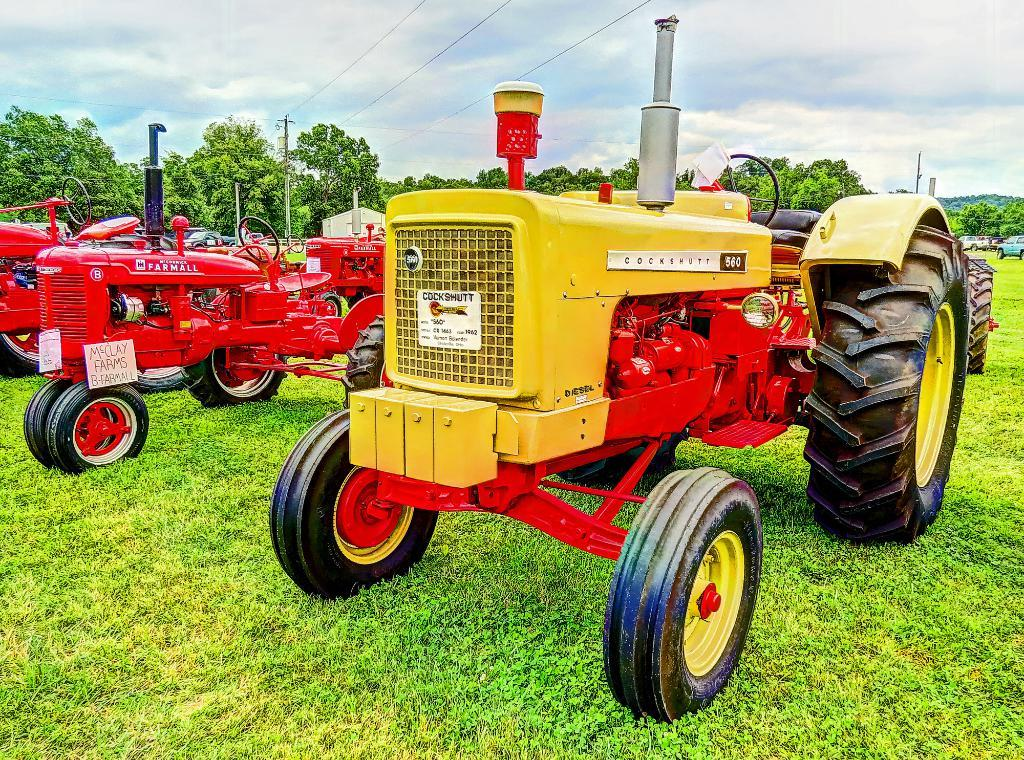What can be seen in large numbers in the image? There are many vehicles and trees in the image. What type of terrain is visible in the image? There is a grassy land in the image. What structures are present in the image? There is an electrical pole in the image. What else can be seen in the image related to the electrical pole? There are cables in the image. What type of guitar can be seen hanging from a branch in the image? There is no guitar or branch present in the image. Can you tell me how many tigers are visible in the image? There are no tigers visible in the image. 